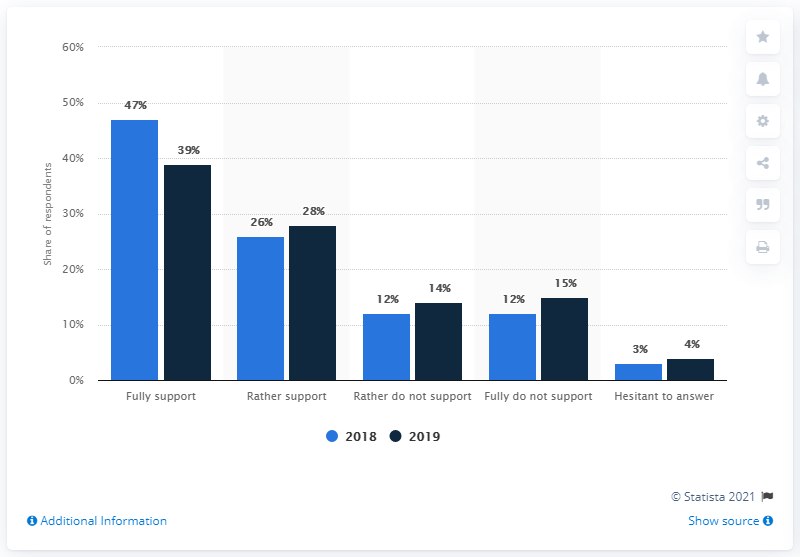Outline some significant characteristics in this image. Four bars are above the value of 20. The average of two bars in Rather Support is 27. 